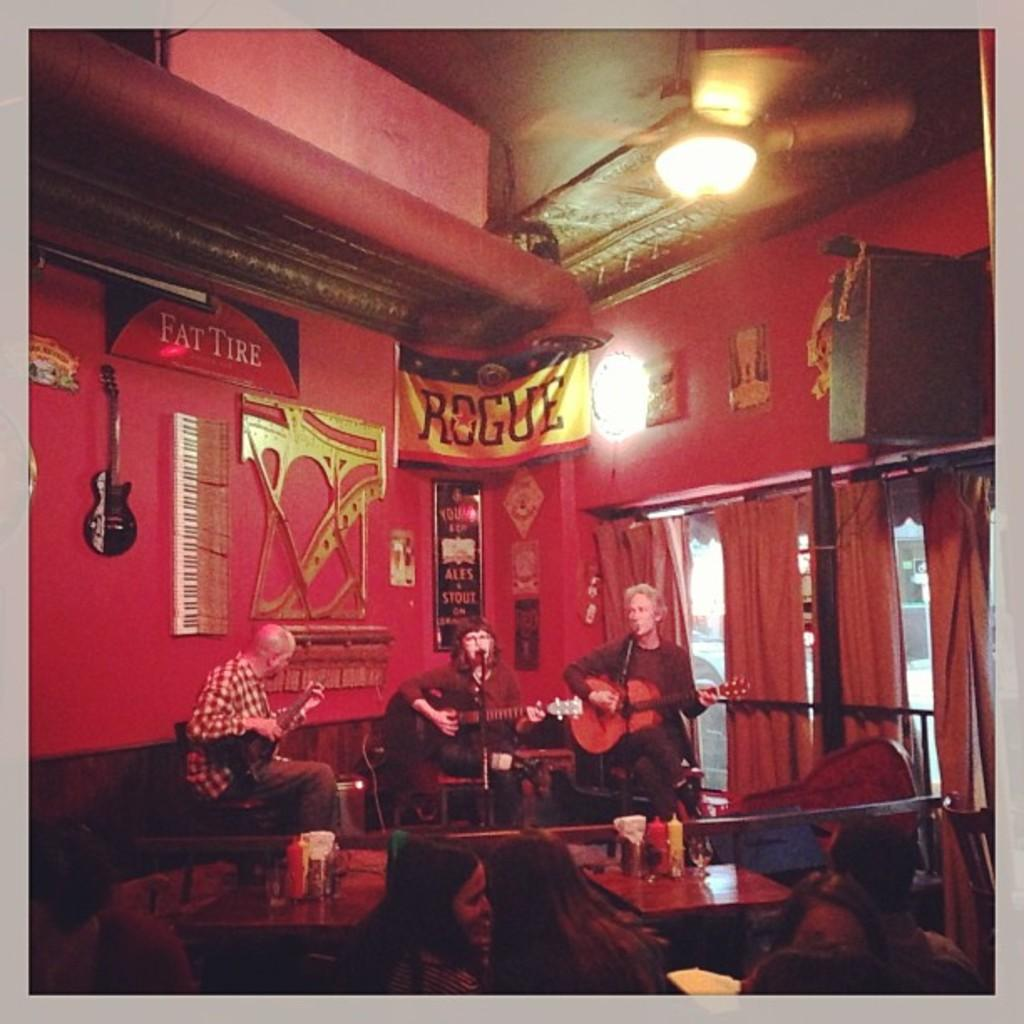Who or what can be seen in the image? There are people in the image. What are the people doing in the image? The people are sitting on chairs and playing guitars. What type of pipe can be seen in the image? There is no pipe present in the image. What kind of cannon is being used by the people in the image? There is no cannon present in the image; the people are playing guitars. 